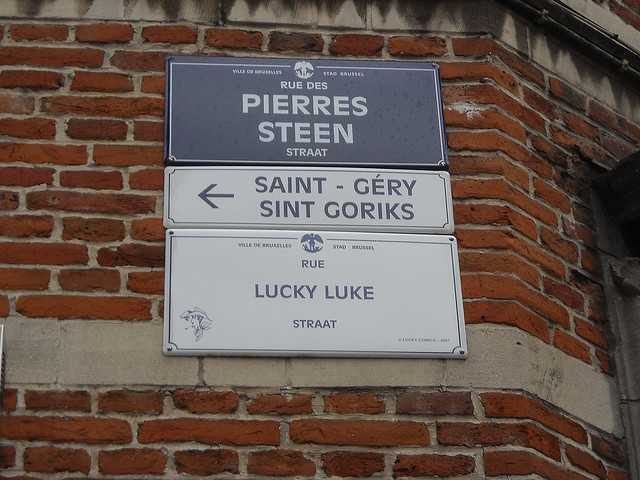<image>Where was this photo taken? It is unknown where this photo was taken. It could be in France, outside of a building, or in a town. Where was this photo taken? I am not sure where this photo was taken. It could be in France or outside of a building. 